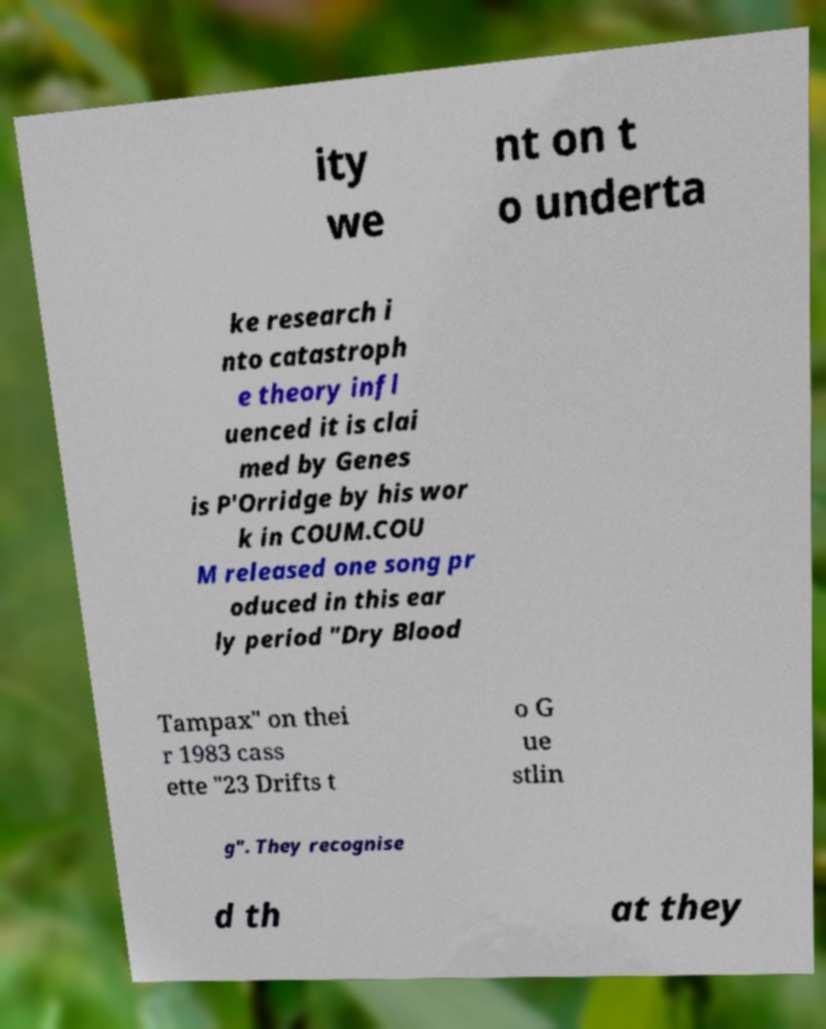For documentation purposes, I need the text within this image transcribed. Could you provide that? ity we nt on t o underta ke research i nto catastroph e theory infl uenced it is clai med by Genes is P'Orridge by his wor k in COUM.COU M released one song pr oduced in this ear ly period "Dry Blood Tampax" on thei r 1983 cass ette "23 Drifts t o G ue stlin g". They recognise d th at they 